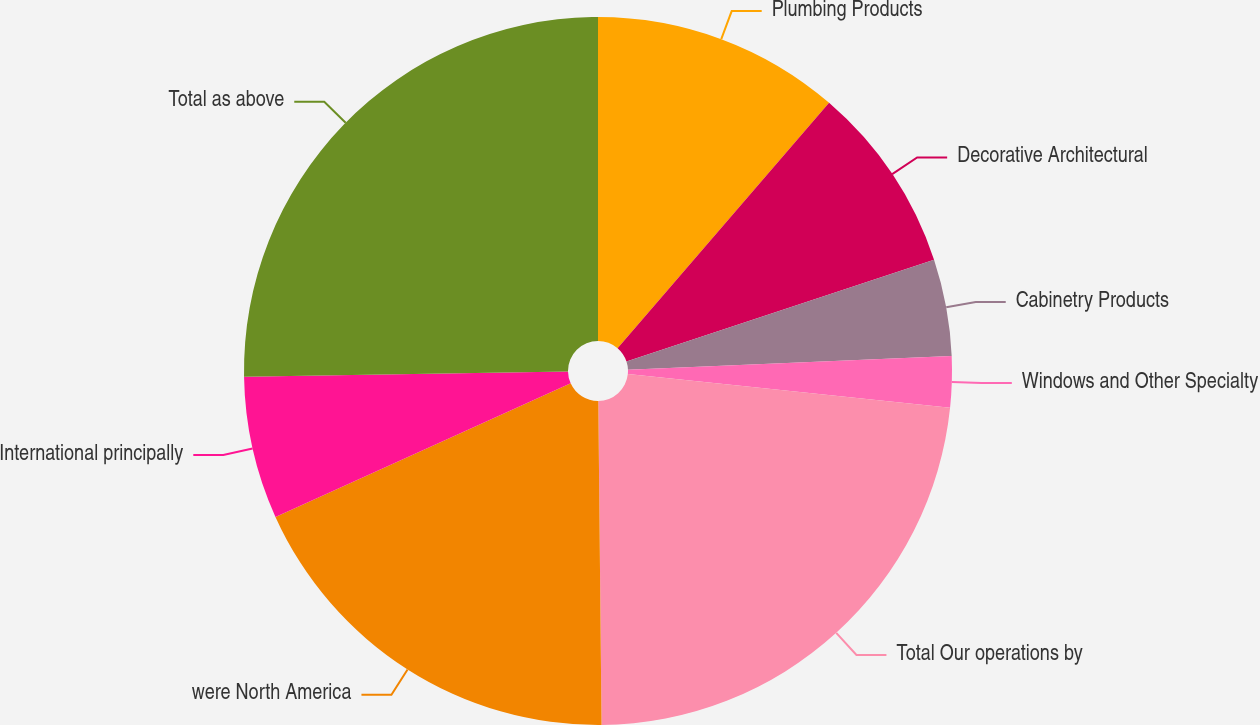<chart> <loc_0><loc_0><loc_500><loc_500><pie_chart><fcel>Plumbing Products<fcel>Decorative Architectural<fcel>Cabinetry Products<fcel>Windows and Other Specialty<fcel>Total Our operations by<fcel>were North America<fcel>International principally<fcel>Total as above<nl><fcel>11.32%<fcel>8.59%<fcel>4.42%<fcel>2.33%<fcel>23.18%<fcel>18.4%<fcel>6.5%<fcel>25.26%<nl></chart> 